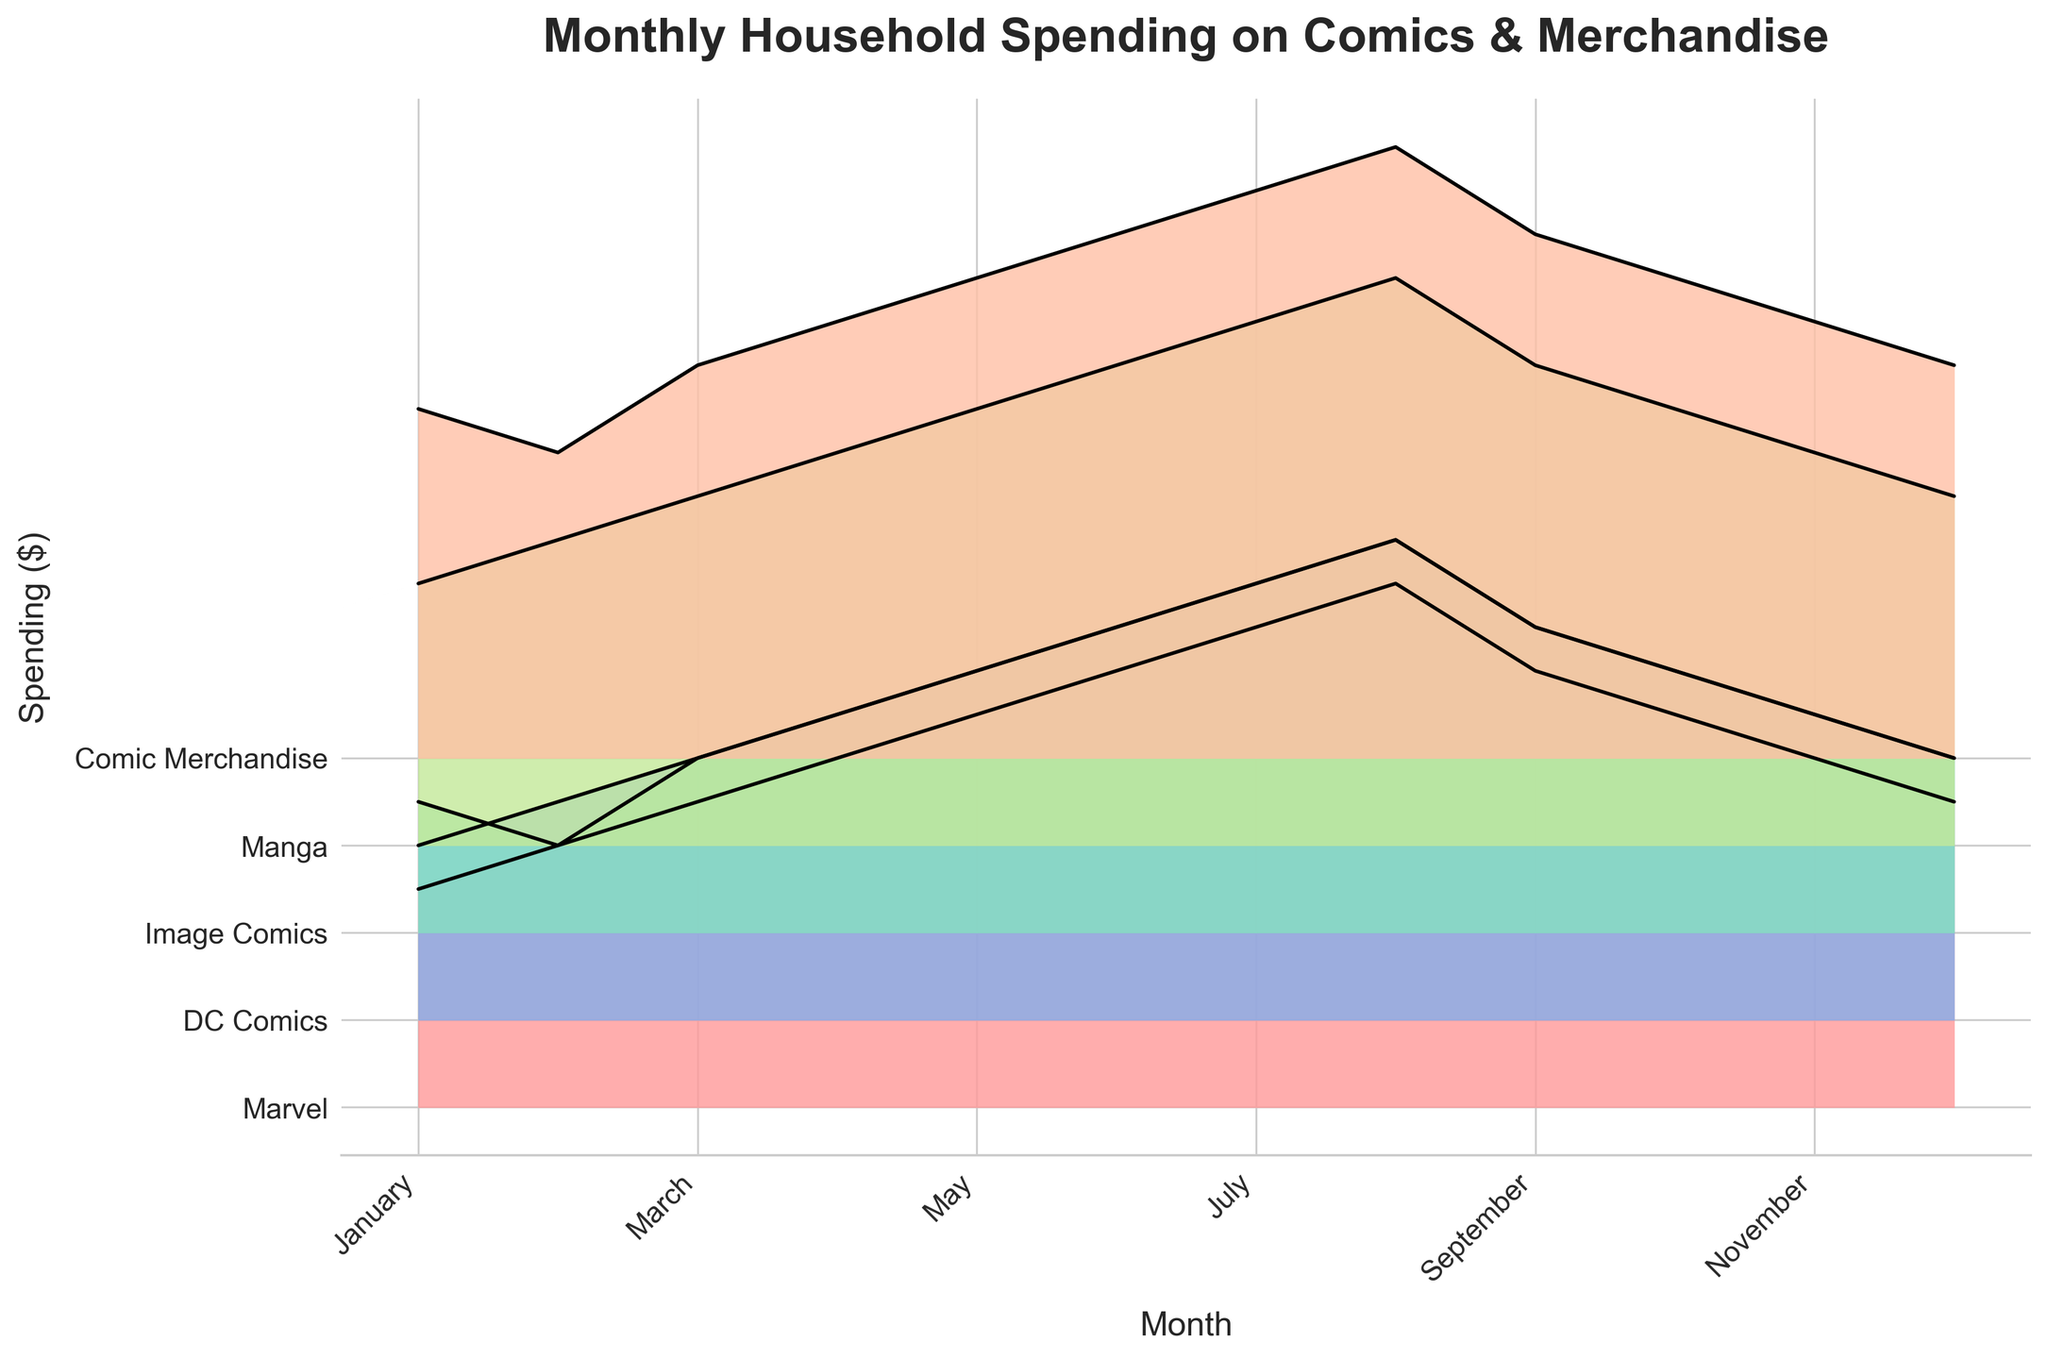What's the title of the plot? The title of the plot is typically found at the top of the figure. Look at the top center of the plot where larger and bold text is usually used to display the title.
Answer: Monthly Household Spending on Comics & Merchandise Which category has the highest spending in July? To find the category with the highest spending in July, look at the ridgeline corresponding to July. Find the highest point within the July section by observing which category rises the most.
Answer: Comic Merchandise How does spending on Marvel comics change from January to August? Follow the ridgeline for Marvel comics from January on the left end of the plot to August on the right end of the plot. Observe the positions and trends visually.
Answer: It steadily increases What is the difference in spending on DC Comics between January and December? Note the spending on DC Comics for January and December by identifying their positions on the y-axis. Subtract the January value from the December value.
Answer: 10 Which months have identical spending patterns for 'Image Comics' and any other category? Compare the ridgelines of Image Comics to other categories across months. Look for months where the two ridgelines are virtually overlapping or have the same values.
Answer: No months have identical spending patterns In what months is spending on 'Manga' higher than 'Marvel'? Compare the height of the ridgelines for Manga and Marvel across all months. Identify the months where Manga ridgeline is higher than that of Marvel.
Answer: January, February, March By how much does spending on 'Comic Merchandise' increase from June to July? Identify the spending on Comic Merchandise for June and compare it to July. Subtract the June value from the July value to find the increase.
Answer: 5 What category has consistently increasing spending from January to August? Review each category's ridgeline from January to August. Identify which one has a smooth upward slope without any decreases.
Answer: All categories During which months does spending on DC Comics exceed spending on Image Comics by at least 10 dollars? Check the ridgelines for DC Comics and Image Comics. Identify the months where the height difference between DC Comics and Image Comics is 10 or more dollars.
Answer: February, March, April, May, July, August, September, November, December What is the total spending on 'Manga' from January to December? Sum the spending values for Manga from each month: 30, 35, 40, 45, 50, 55, 60, 65, 55, 50, 45, 40. This calculation involves adding up all the monthly Manga spending values visually presented in the ridgeline.
Answer: 570 